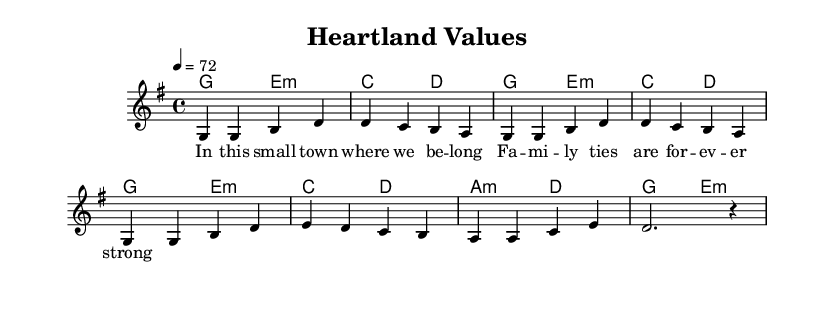What is the key signature of this music? The key signature indicates G major, which has one sharp (F#). This is evident from the notation at the beginning of the staff where the F# is represented, confirming it is in G major.
Answer: G major What is the time signature of this music? The time signature is found at the beginning, indicated by the fraction, which shows the music is arranged in four beats per measure. This is represented as 4/4, meaning there are four quarter-note beats in each measure.
Answer: 4/4 What is the tempo marking of this music? The tempo marking is found below the title in the global section, indicating the speed at which the music should be played. Here, it is set to quarter note equals seventy-two beats per minute, giving a moderate pace to the piece.
Answer: 72 How many measures are in the first verse? The first verse is presented in two sections: the first has 8 measures of melody and harmonies. Each line has 4 measures, and since there are 2 lines in the verse, we add 4 + 4 to get the total.
Answer: 8 Which chord appears most frequently in the harmony section? By analyzing the chord progressions written in the harmonies, we can see that the G major chord appears in every measure, making it the most recurring chord in this section.
Answer: G What lyrical theme is presented in the verse? The lyrics of the verse speak about the importance of family ties in a small town, emphasizing strong relationships that are everlasting. This relation to family values is prevalent throughout the song.
Answer: Family ties 